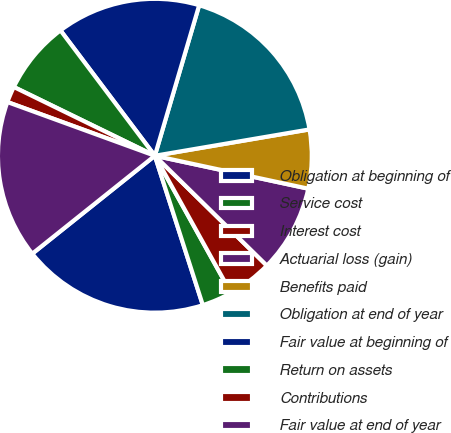Convert chart to OTSL. <chart><loc_0><loc_0><loc_500><loc_500><pie_chart><fcel>Obligation at beginning of<fcel>Service cost<fcel>Interest cost<fcel>Actuarial loss (gain)<fcel>Benefits paid<fcel>Obligation at end of year<fcel>Fair value at beginning of<fcel>Return on assets<fcel>Contributions<fcel>Fair value at end of year<nl><fcel>19.22%<fcel>3.12%<fcel>4.59%<fcel>8.98%<fcel>6.05%<fcel>17.76%<fcel>14.83%<fcel>7.51%<fcel>1.66%<fcel>16.29%<nl></chart> 